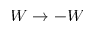<formula> <loc_0><loc_0><loc_500><loc_500>W \to - W</formula> 